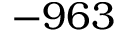Convert formula to latex. <formula><loc_0><loc_0><loc_500><loc_500>- 9 6 3</formula> 